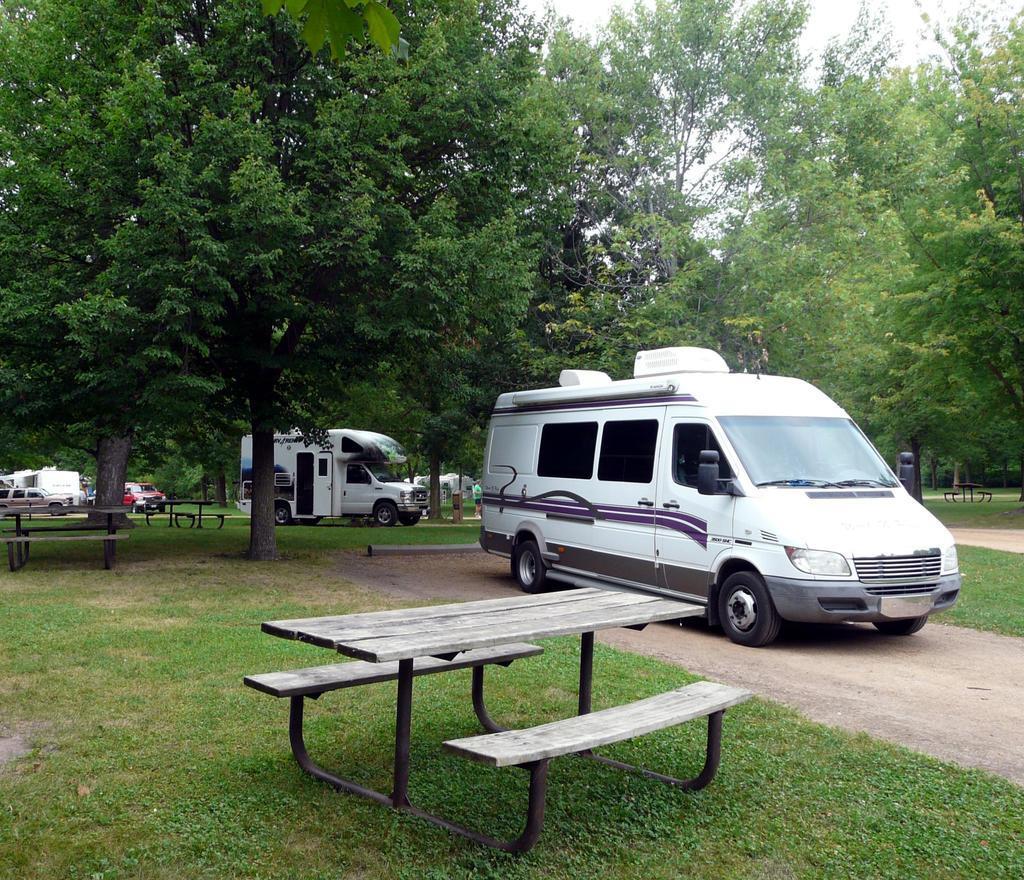Please provide a concise description of this image. In this picture we can see a bench in the grass, vehicles and couple of trees. 